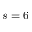<formula> <loc_0><loc_0><loc_500><loc_500>s = 6</formula> 